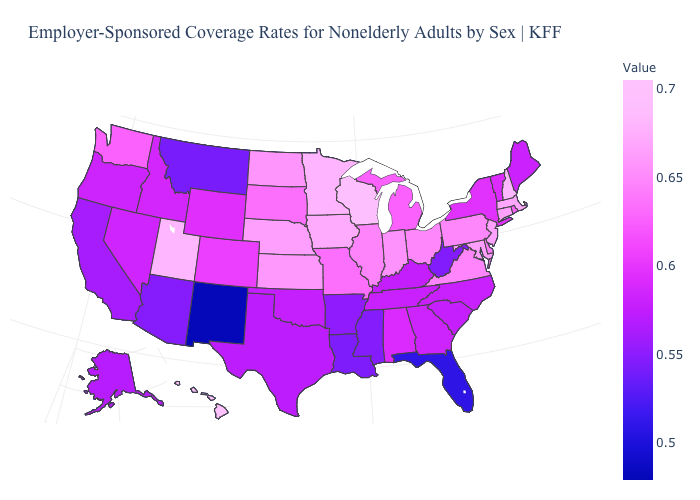Does the map have missing data?
Be succinct. No. Does Mississippi have the highest value in the USA?
Concise answer only. No. Which states have the highest value in the USA?
Quick response, please. Hawaii. Does Kansas have the lowest value in the MidWest?
Quick response, please. No. Which states have the highest value in the USA?
Answer briefly. Hawaii. Among the states that border Nebraska , which have the highest value?
Short answer required. Iowa. 